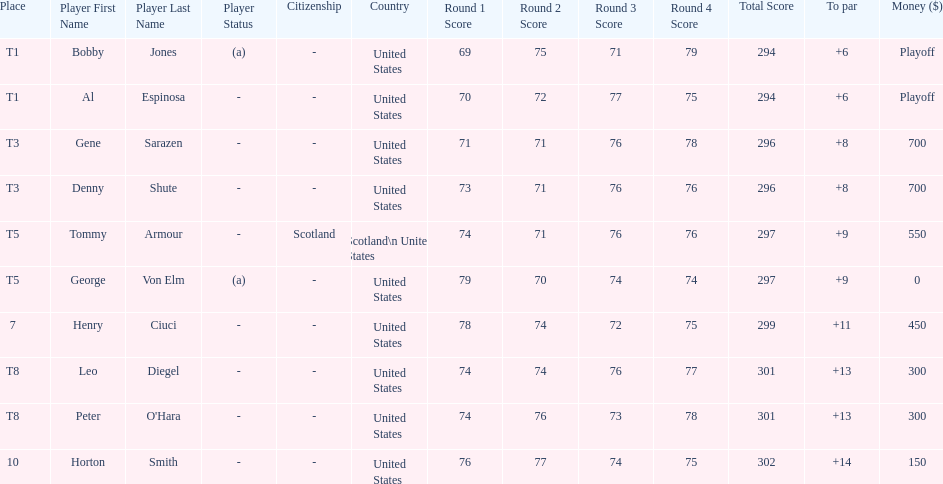What was al espinosa's total stroke count at the final of the 1929 us open? 294. 